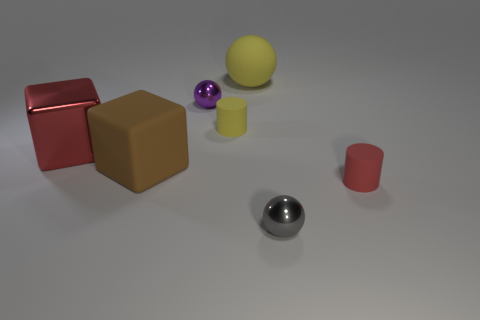What size is the sphere that is on the right side of the small purple ball and behind the large red shiny block?
Your answer should be very brief. Large. Is there a small shiny thing that has the same shape as the big yellow thing?
Give a very brief answer. Yes. What number of red objects have the same shape as the small gray metallic thing?
Offer a very short reply. 0. Do the metal sphere that is behind the big red object and the block that is behind the big brown object have the same size?
Your answer should be very brief. No. There is a large matte object behind the yellow matte object that is in front of the big yellow matte ball; what shape is it?
Your answer should be compact. Sphere. Are there an equal number of tiny gray objects in front of the small yellow rubber cylinder and rubber blocks?
Ensure brevity in your answer.  Yes. What is the purple object that is on the left side of the small sphere that is in front of the shiny object that is on the left side of the small purple sphere made of?
Give a very brief answer. Metal. Is there a blue metal sphere that has the same size as the red block?
Give a very brief answer. No. The tiny gray shiny object has what shape?
Ensure brevity in your answer.  Sphere. How many spheres are either small gray things or large objects?
Ensure brevity in your answer.  2. 